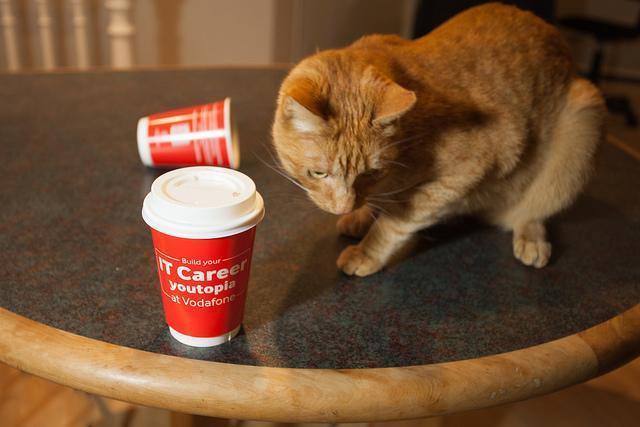How many cups have lids on them?
Give a very brief answer. 1. How many cups are in the picture?
Give a very brief answer. 2. 